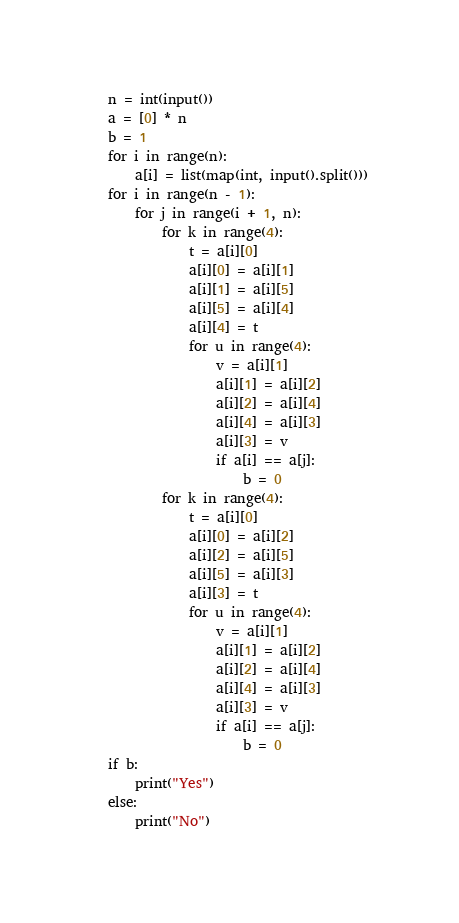Convert code to text. <code><loc_0><loc_0><loc_500><loc_500><_Python_>n = int(input())
a = [0] * n
b = 1
for i in range(n):
	a[i] = list(map(int, input().split()))
for i in range(n - 1):
	for j in range(i + 1, n):
		for k in range(4):
			t = a[i][0]
			a[i][0] = a[i][1]
			a[i][1] = a[i][5]
			a[i][5] = a[i][4]
			a[i][4] = t
			for u in range(4):
				v = a[i][1]
				a[i][1] = a[i][2]
				a[i][2] = a[i][4]
				a[i][4] = a[i][3]
				a[i][3] = v
				if a[i] == a[j]:
					b = 0
		for k in range(4):
			t = a[i][0]
			a[i][0] = a[i][2]
			a[i][2] = a[i][5]
			a[i][5] = a[i][3]
			a[i][3] = t
			for u in range(4):
				v = a[i][1]
				a[i][1] = a[i][2]
				a[i][2] = a[i][4]
				a[i][4] = a[i][3]
				a[i][3] = v
				if a[i] == a[j]:
					b = 0
if b:
	print("Yes")
else:
	print("No")
</code> 